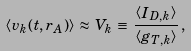<formula> <loc_0><loc_0><loc_500><loc_500>\left < v _ { k } ( t , r _ { A } ) \right > \, \approx \, V _ { k } \, \equiv \, \frac { \left < I _ { D , k } \right > } { \left < g _ { T , k } \right > } \, ,</formula> 